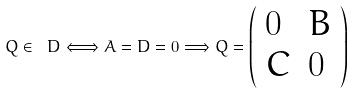Convert formula to latex. <formula><loc_0><loc_0><loc_500><loc_500>Q \in \ D \Longleftrightarrow A = D = 0 \Longrightarrow Q = \left ( \begin{array} { l l } 0 & B \\ C & 0 \end{array} \right )</formula> 